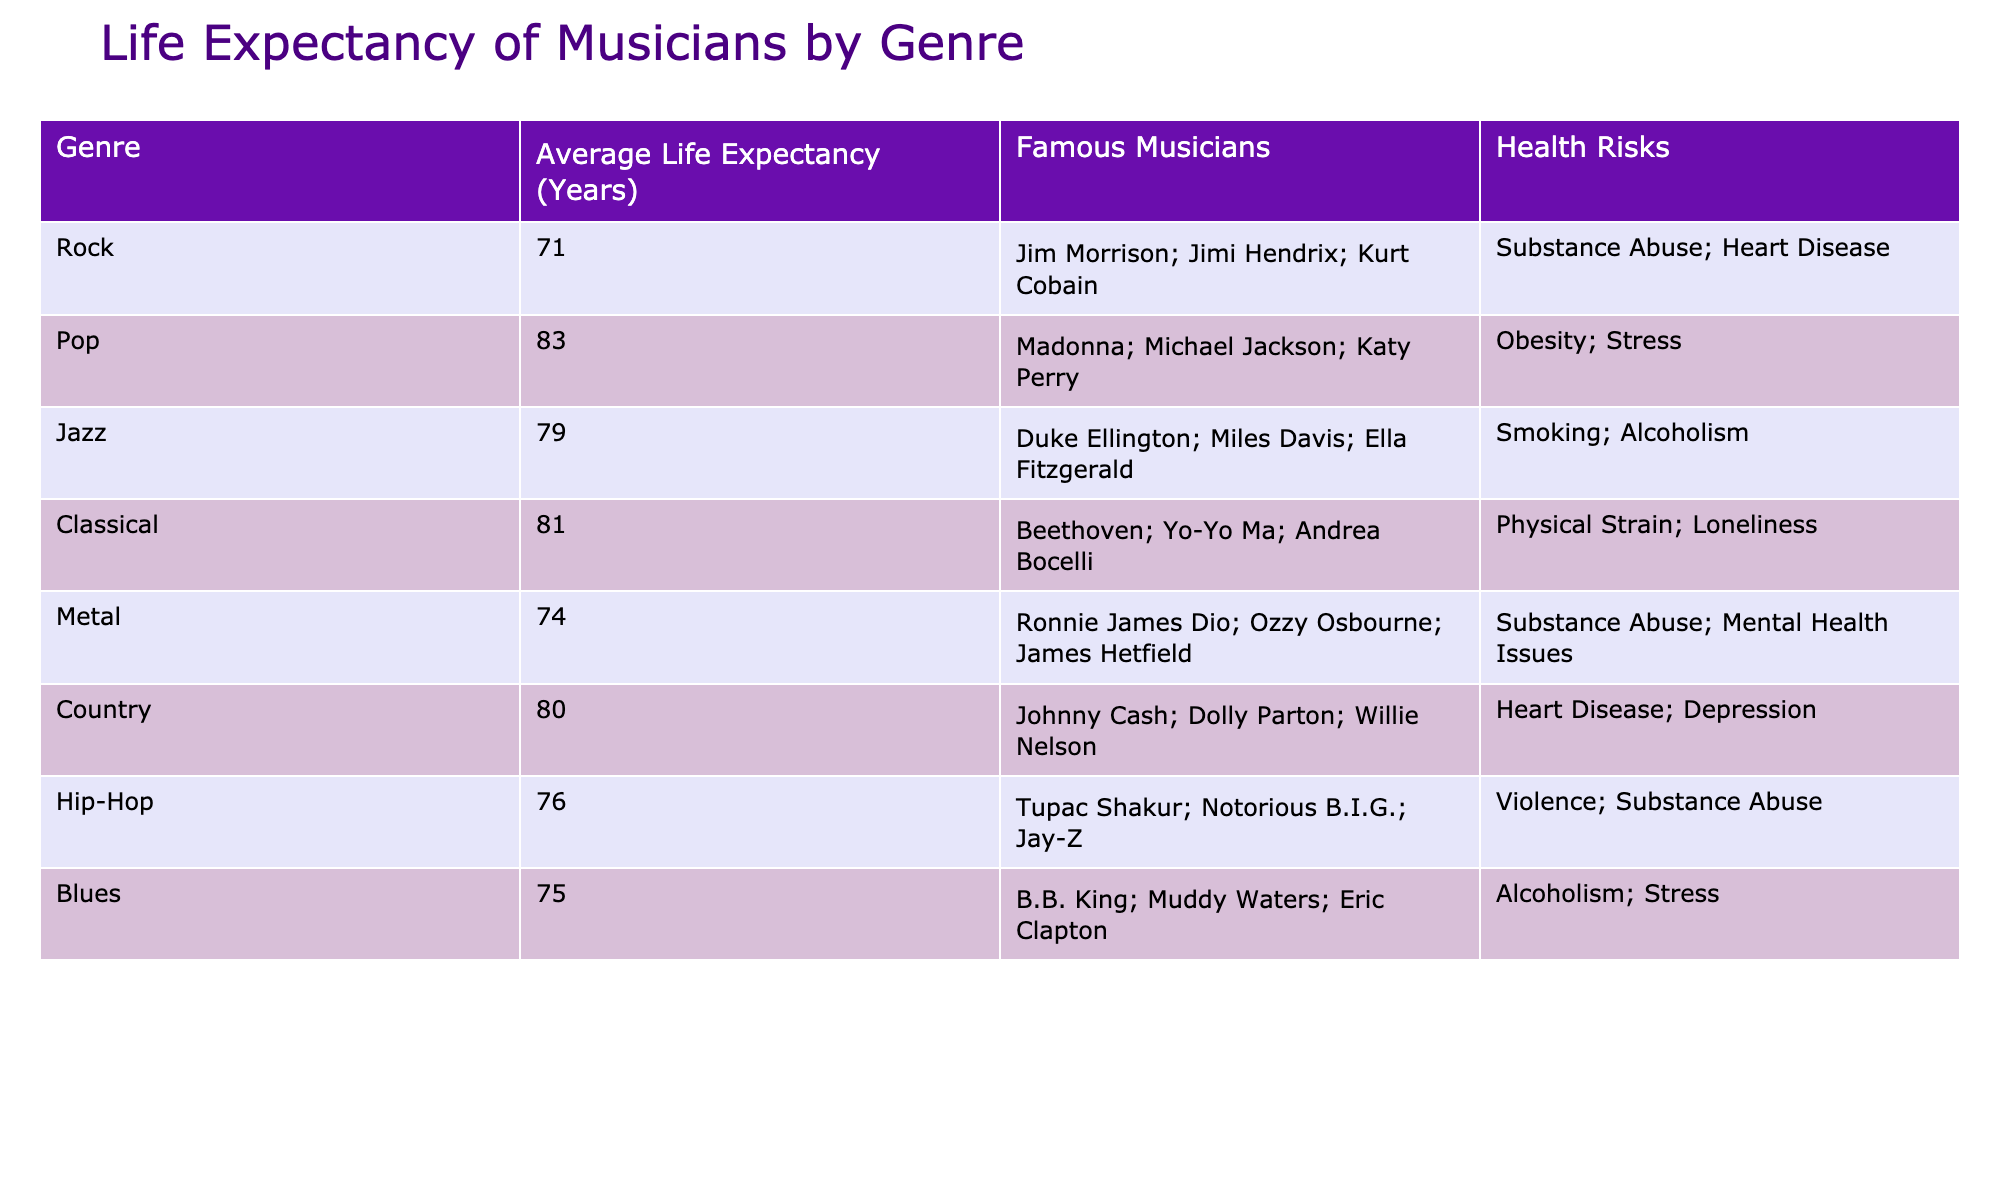What is the average life expectancy of rock musicians? The table lists the average life expectancy for rock musicians as 71 years. This is directly stated in the corresponding cell under the 'Average Life Expectancy (Years)' for the 'Rock' genre.
Answer: 71 Which genre has the highest life expectancy? By comparing the average life expectancy values across all genres in the table, pop musicians have the highest average life expectancy of 83 years. This information is found by scanning through the values in that column.
Answer: 83 What health risk is associated with jazz musicians? The health risk listed for jazz musicians is smoking and alcoholism as per the 'Health Risks' column corresponding to the 'Jazz' genre. This can be found by looking at the relevant row for jazz in the table.
Answer: Smoking; Alcoholism How much shorter is the average life expectancy of metal musicians compared to classical musicians? To find the difference, subtract the average life expectancy of metal musicians (74 years) from that of classical musicians (81 years). The calculation shows 81 - 74 = 7 years, indicating that metal musicians have a life expectancy that is 7 years shorter than classical musicians.
Answer: 7 years Is it true that country musicians have a higher average life expectancy than hip-hop musicians? Yes, examining the average life expectancy values indicates that country musicians average 80 years while hip-hop musicians average 76 years, confirming that country musicians have a higher life expectancy than hip-hop musicians.
Answer: Yes What is the average life expectancy of musicians in genres with health risks related to substance abuse? The genres associated with substance abuse are rock, metal, and hip-hop, with their average life expectancies being 71, 74, and 76 years, respectively. To find the average, sum these values (71 + 74 + 76 = 221) and divide by the number of genres (3), resulting in an average of 221 / 3 = 73.67 years.
Answer: 73.67 Which genre has an average life expectancy closest to the overall average of the data presented? First, calculate the overall average life expectancy for all listed genres: (71 + 83 + 79 + 81 + 74 + 80 + 76 + 75) / 8 = 77.875 years. Then, compare this to the values of each genre to find which is closest. Blues at 75 years is the closest, differing only by 2.875 years.
Answer: 75 What do the health risks for pop musicians indicate about their lifestyle? Pop musicians face health risks primarily related to obesity and stress as noted in the table. This suggests that their lifestyle may involve factors associated with high-stress environments and potentially unhealthy eating habits or weight management issues.
Answer: Obesity; Stress 